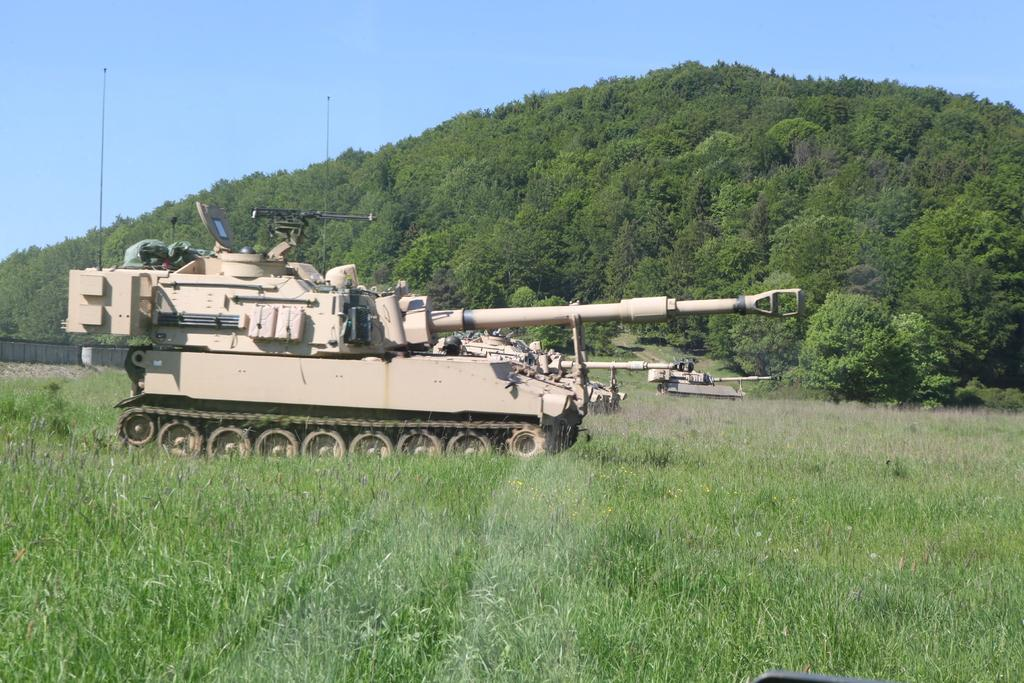What type of vehicles are present in the image? There are tanks in the image. What type of vegetation can be seen in the image? There is grass, plants, and trees in the image. What part of the natural environment is visible in the image? The sky is visible in the background of the image. What type of yarn is being used to create the crime scene in the image? There is no crime scene or yarn present in the image; it features tanks and vegetation. What type of leather is visible on the tanks in the image? There is no leather present on the tanks in the image. 